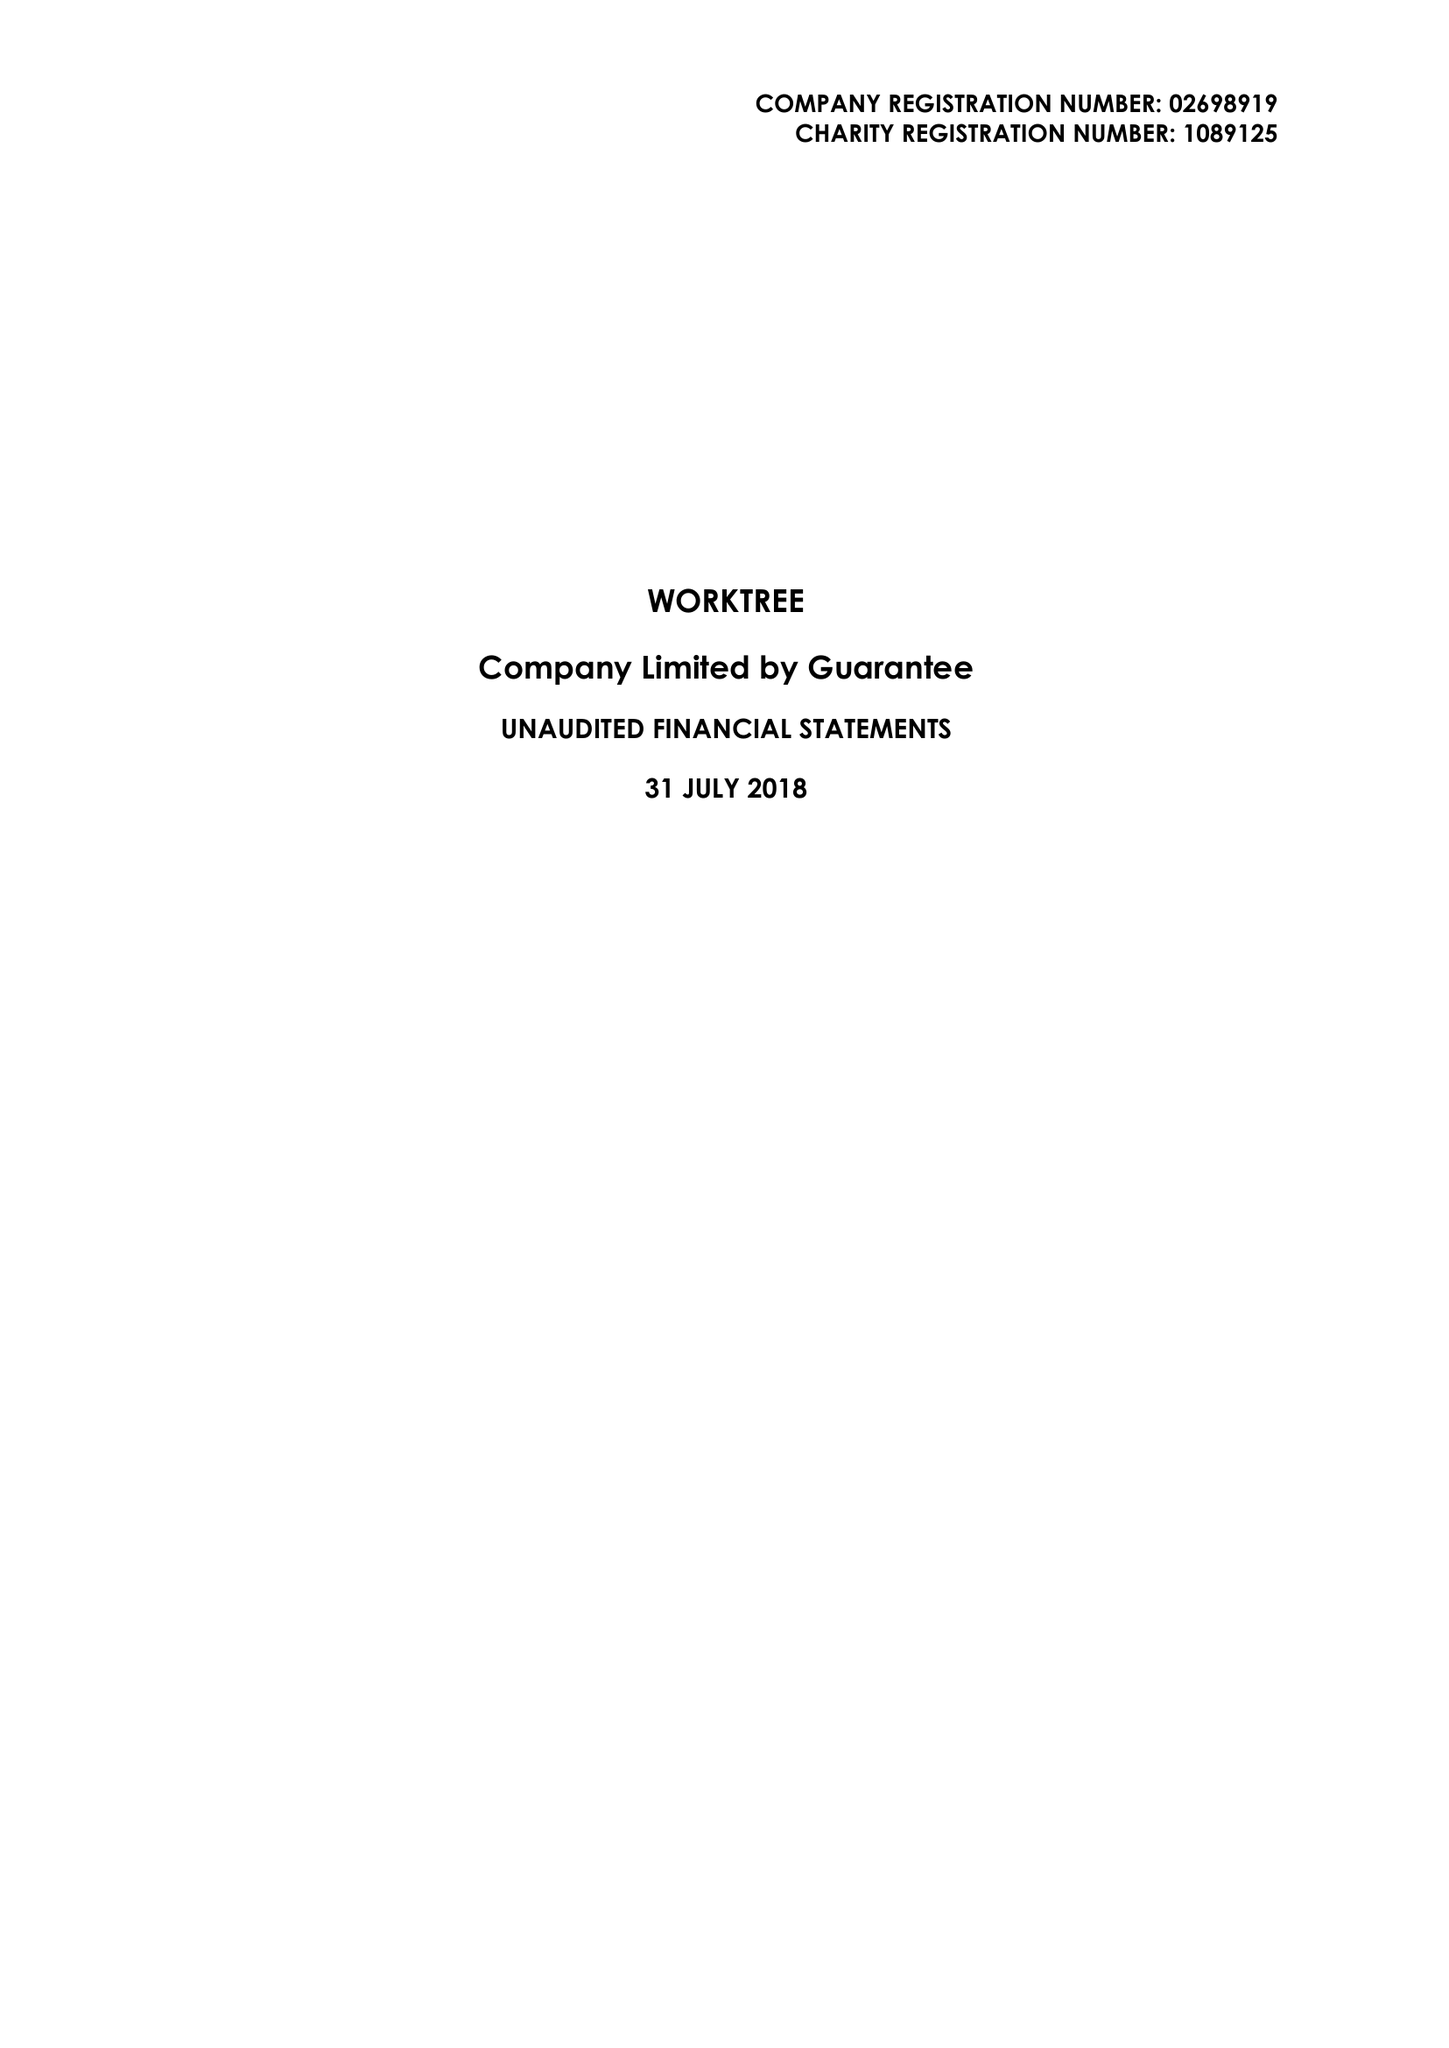What is the value for the charity_name?
Answer the question using a single word or phrase. Worktree 